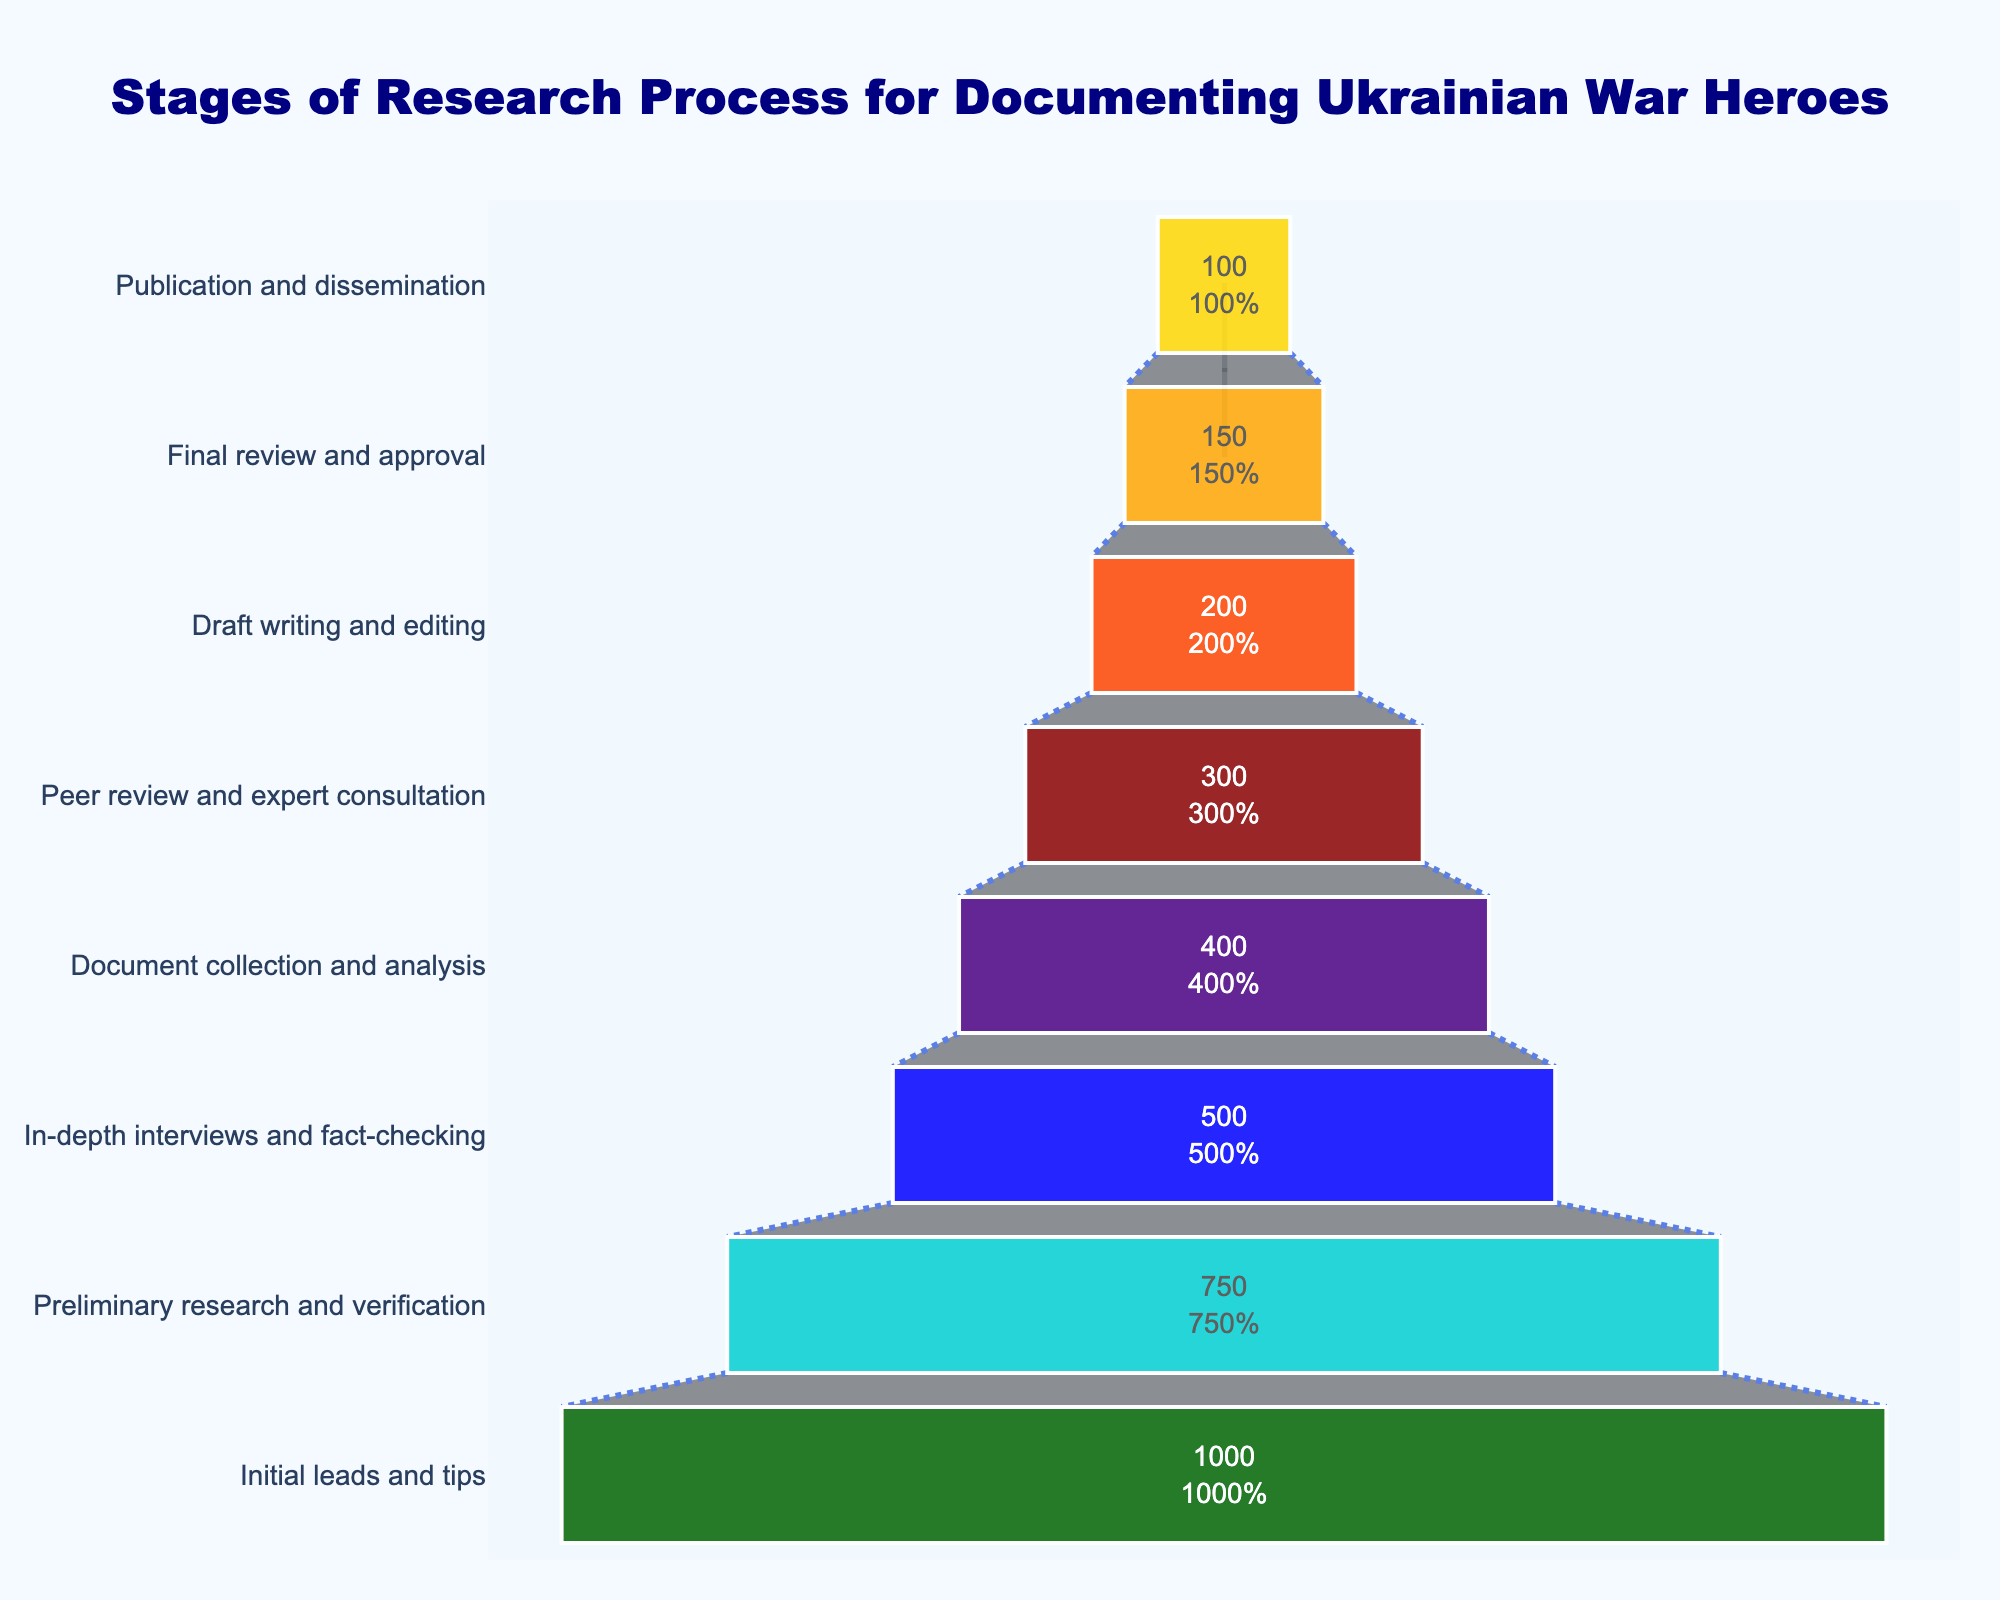what is the value shown for the publication and dissemination stage? The last stage "Publication and dissemination" shows the final value at the smallest part of the funnel chart.
Answer: 100 Which stage has the highest number of cases? The topmost stage of the funnel represents the initial point with the highest number.
Answer: Initial leads and tips How many stages are depicted in the funnel? Count the number of distinct stages listed along the y-axis of the funnel chart.
Answer: 8 What's the difference in the number of cases between "Initial leads and tips" and "Final review and approval"? Subtract the number of cases for "Final review and approval" from the number for "Initial leads and tips" (1000 - 150).
Answer: 850 At what stage does the number of cases drop below 500? Examine the stages from top to bottom; the stage just below 500 is "In-depth interviews and fact-checking".
Answer: Document collection and analysis How many cases are lost between the "Preliminary research and verification" and "In-depth interviews and fact-checking"? Subtract the number of cases in "In-depth interviews and fact-checking" from "Preliminary research and verification" (750 - 500).
Answer: 250 Which stage immediately precedes the "Peer review and expert consultation"? The stage listed directly above "Peer review and expert consultation" is "Document collection and analysis".
Answer: Document collection and analysis What percentage of the initial leads and tips reach the publication and dissemination stage? Divide the number of cases in the publication stage by the initial leads and then multiply by 100 to get the percentage ((100 / 1000) * 100).
Answer: 10% Is there a stage where the number of cases reduces by exactly 50% from the previous stage? Check each stage to see if the cases match half of the previous stage. (150 is half of 300).
Answer: Yes, the "Final review and approval" stage What is the combined total number of cases for the stages "Draft writing and editing" and "Document collection and analysis"? Add the number of cases for the two stages (200 + 400).
Answer: 600 